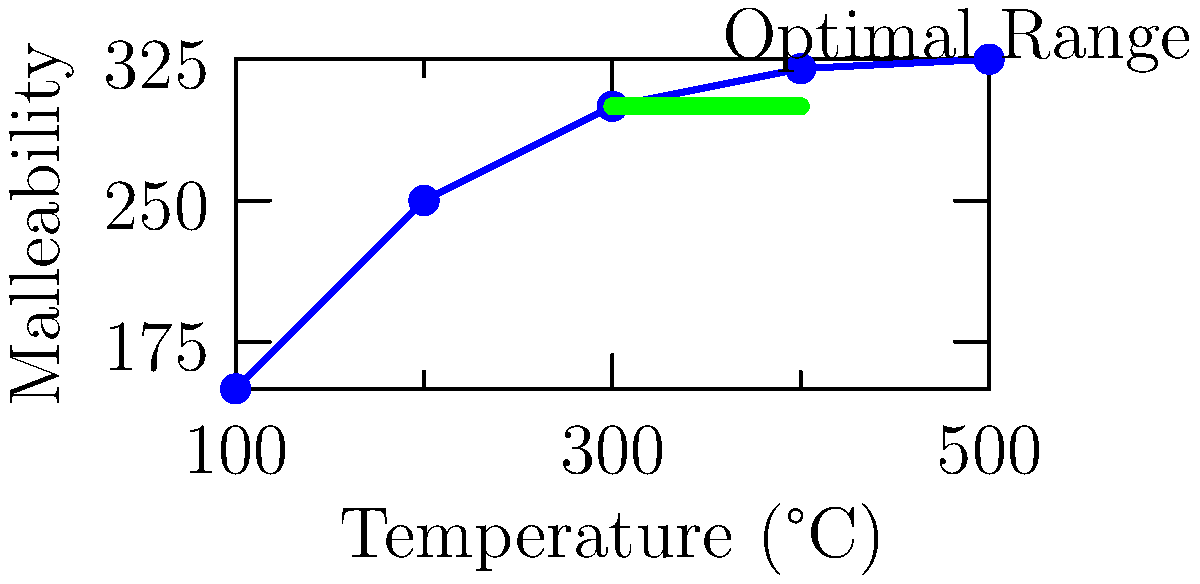Based on the thermal imaging data represented in the graph, which temperature range would you recommend for achieving optimal malleability when working with copper sheets for crafting pots and pans? To determine the optimal heating temperature for copper sheets, we need to analyze the graph:

1. The x-axis represents temperature in °C, and the y-axis represents malleability.
2. As temperature increases, malleability generally increases.
3. The curve shows a steep rise in malleability from 100°C to 300°C.
4. Between 300°C and 400°C, the rate of increase in malleability slows down significantly.
5. After 400°C, the curve almost flattens, indicating minimal gains in malleability.
6. The graph highlights an "Optimal Range" with a green line between 300°C and 400°C.

Given this analysis:
- Below 300°C, the copper is not malleable enough for efficient shaping.
- Above 400°C, there's little additional benefit in malleability, and excessive heat could potentially damage the copper's structure.
- The 300-400°C range provides the best balance of malleability without risking overheating.

Therefore, the optimal temperature range for working with copper sheets to craft pots and pans is between 300°C and 400°C.
Answer: 300-400°C 